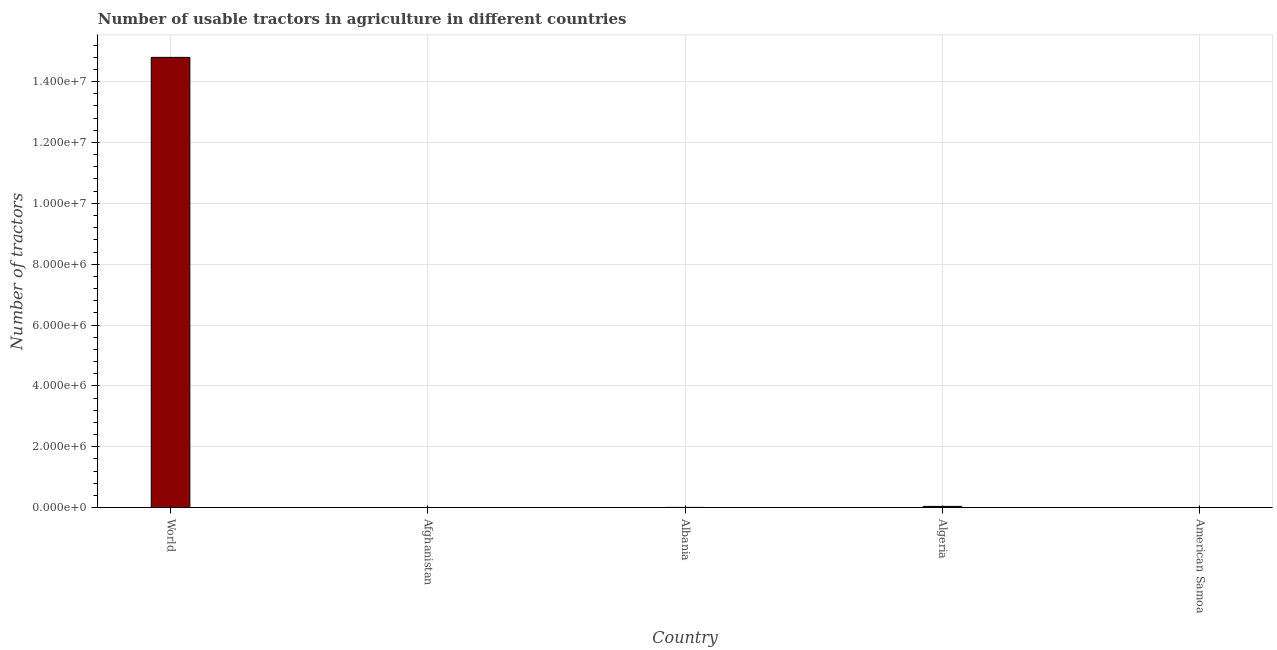Does the graph contain any zero values?
Provide a short and direct response. No. Does the graph contain grids?
Your answer should be compact. Yes. What is the title of the graph?
Provide a succinct answer. Number of usable tractors in agriculture in different countries. What is the label or title of the Y-axis?
Offer a very short reply. Number of tractors. What is the number of tractors in Albania?
Offer a very short reply. 8184. Across all countries, what is the maximum number of tractors?
Provide a short and direct response. 1.48e+07. Across all countries, what is the minimum number of tractors?
Offer a very short reply. 12. In which country was the number of tractors minimum?
Your response must be concise. American Samoa. What is the sum of the number of tractors?
Offer a very short reply. 1.48e+07. What is the difference between the number of tractors in Algeria and World?
Your answer should be compact. -1.48e+07. What is the average number of tractors per country?
Your answer should be very brief. 2.97e+06. What is the median number of tractors?
Offer a terse response. 8184. What is the difference between the highest and the second highest number of tractors?
Your answer should be very brief. 1.48e+07. What is the difference between the highest and the lowest number of tractors?
Offer a terse response. 1.48e+07. In how many countries, is the number of tractors greater than the average number of tractors taken over all countries?
Offer a very short reply. 1. How many countries are there in the graph?
Your answer should be compact. 5. What is the difference between two consecutive major ticks on the Y-axis?
Make the answer very short. 2.00e+06. Are the values on the major ticks of Y-axis written in scientific E-notation?
Give a very brief answer. Yes. What is the Number of tractors in World?
Provide a short and direct response. 1.48e+07. What is the Number of tractors of Afghanistan?
Keep it short and to the point. 585. What is the Number of tractors in Albania?
Keep it short and to the point. 8184. What is the Number of tractors in Algeria?
Your answer should be very brief. 4.10e+04. What is the Number of tractors of American Samoa?
Your answer should be compact. 12. What is the difference between the Number of tractors in World and Afghanistan?
Provide a succinct answer. 1.48e+07. What is the difference between the Number of tractors in World and Albania?
Keep it short and to the point. 1.48e+07. What is the difference between the Number of tractors in World and Algeria?
Ensure brevity in your answer.  1.48e+07. What is the difference between the Number of tractors in World and American Samoa?
Provide a short and direct response. 1.48e+07. What is the difference between the Number of tractors in Afghanistan and Albania?
Your answer should be compact. -7599. What is the difference between the Number of tractors in Afghanistan and Algeria?
Provide a succinct answer. -4.04e+04. What is the difference between the Number of tractors in Afghanistan and American Samoa?
Keep it short and to the point. 573. What is the difference between the Number of tractors in Albania and Algeria?
Keep it short and to the point. -3.28e+04. What is the difference between the Number of tractors in Albania and American Samoa?
Make the answer very short. 8172. What is the difference between the Number of tractors in Algeria and American Samoa?
Your response must be concise. 4.10e+04. What is the ratio of the Number of tractors in World to that in Afghanistan?
Offer a terse response. 2.53e+04. What is the ratio of the Number of tractors in World to that in Albania?
Offer a terse response. 1807.83. What is the ratio of the Number of tractors in World to that in Algeria?
Your response must be concise. 360.86. What is the ratio of the Number of tractors in World to that in American Samoa?
Your answer should be very brief. 1.23e+06. What is the ratio of the Number of tractors in Afghanistan to that in Albania?
Offer a very short reply. 0.07. What is the ratio of the Number of tractors in Afghanistan to that in Algeria?
Your answer should be compact. 0.01. What is the ratio of the Number of tractors in Afghanistan to that in American Samoa?
Make the answer very short. 48.75. What is the ratio of the Number of tractors in Albania to that in American Samoa?
Offer a terse response. 682. What is the ratio of the Number of tractors in Algeria to that in American Samoa?
Your answer should be compact. 3416.67. 